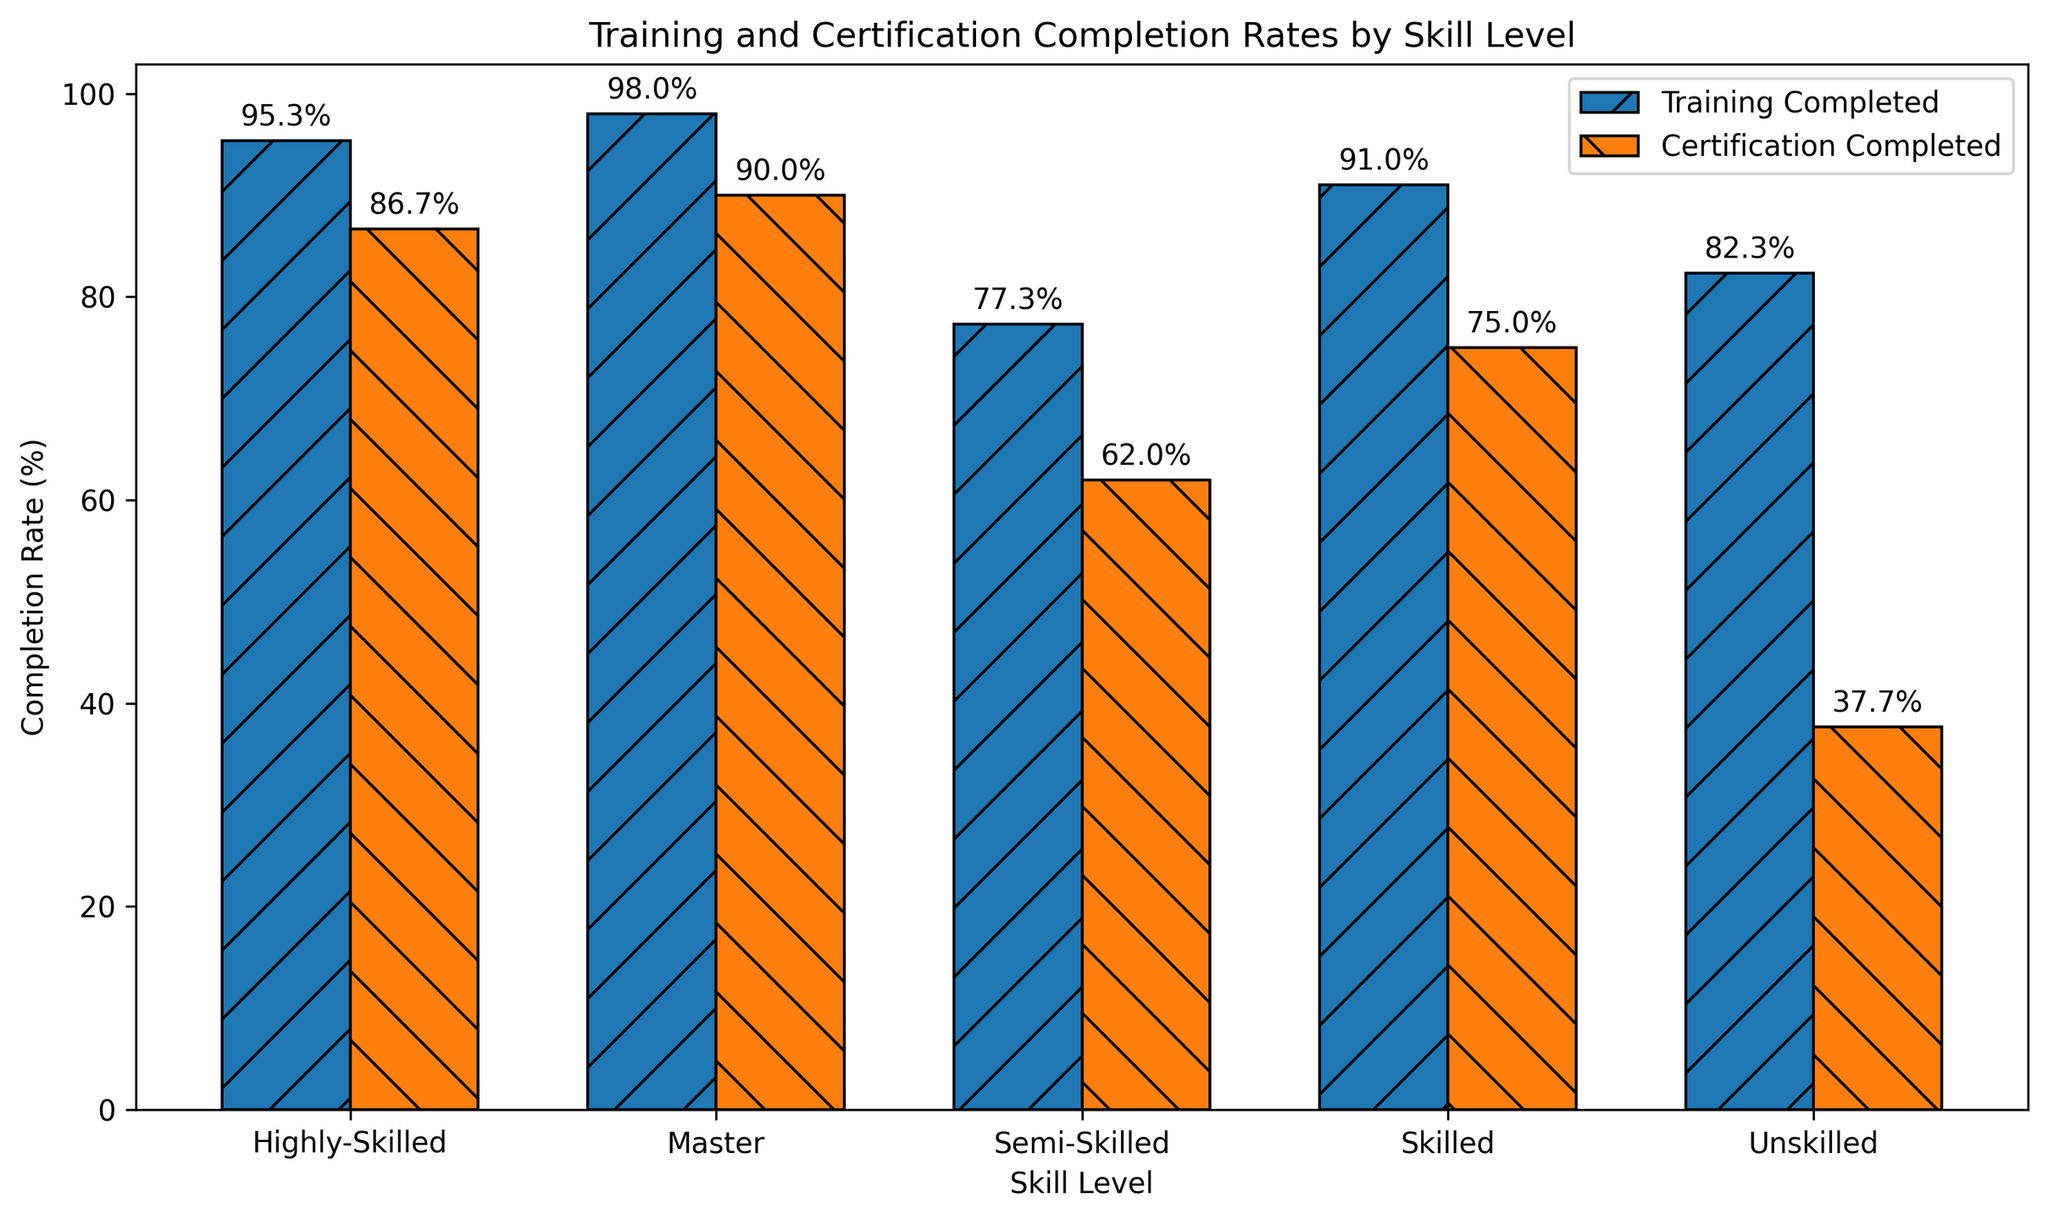Which skill level has the highest training completion rate? Observing the height of the bars representing 'Training Completed', the highest bar belongs to the 'Master' skill level.
Answer: Master Which skill level has the lowest certification completion rate? Comparing the heights of the bars representing 'Certification Completed', the smallest bar is for the 'Unskilled' level.
Answer: Unskilled By how much does the certification completion rate for 'Highly-Skilled' workers exceed that of 'Semi-Skilled' workers? The 'Highly-Skilled' certification completion rate is 87%, and for 'Semi-Skilled' it is 62%. The difference is 87% - 62% = 25%.
Answer: 25% What is the average training completion rate for 'Unskilled' and 'Semi-Skilled' workers? The training completion rates are 82.3% for 'Unskilled' and 77.3% for 'Semi-Skilled'. The average is (82.3% + 77.3%) / 2 = 79.8%.
Answer: 79.8% What is the difference in training completion rates between 'Skilled' and 'Unskilled' workers? The 'Skilled' training rate is 91%, and the 'Unskilled' training rate is 82.3%. The difference is 91% - 82.3% = 8.7%.
Answer: 8.7% Which has a higher completion rate, 'Semi-Skilled' training or 'Skilled' certification? The 'Semi-Skilled' training completion rate is 77.3%, and the 'Skilled' certification completion rate is 75%. Since 77.3% > 75%, 'Semi-Skilled' training has a higher rate.
Answer: Semi-Skilled training What is the approximate percentage difference between training and certification completion rates for 'Master' level workers? The 'Master' level training rate is 98%, and the certification rate is 90%. The percentage difference is calculated as (98% - 90%) / 98% * 100% ≈ 8.16%.
Answer: 8.16% What is the total sum of certification completion rates for all skill levels? Summing up the certification rates for all skill levels: 38 (Unskilled) + 62 (Semi-Skilled) + 75 (Skilled) + 87 (Highly-Skilled) + 90 (Master) = 352%.
Answer: 352% Is the training completion rate higher for 'Highly-Skilled' workers than for 'Skilled' workers? The training rates are 95% for 'Highly-Skilled' and 91% for 'Skilled'. Since 95% > 91%, the training rate for 'Highly-Skilled' is higher.
Answer: Yes How much higher is the average training completion rate than the average certification completion rate across all skill levels? The average training rate is (82.3 + 77.3 + 91 + 95 + 98) / 5 = 88.72%. The average certification rate is (38 + 62 + 75 + 87 + 90) / 5 = 70.4%. The difference is 88.72% - 70.4% = 18.32%.
Answer: 18.32% 